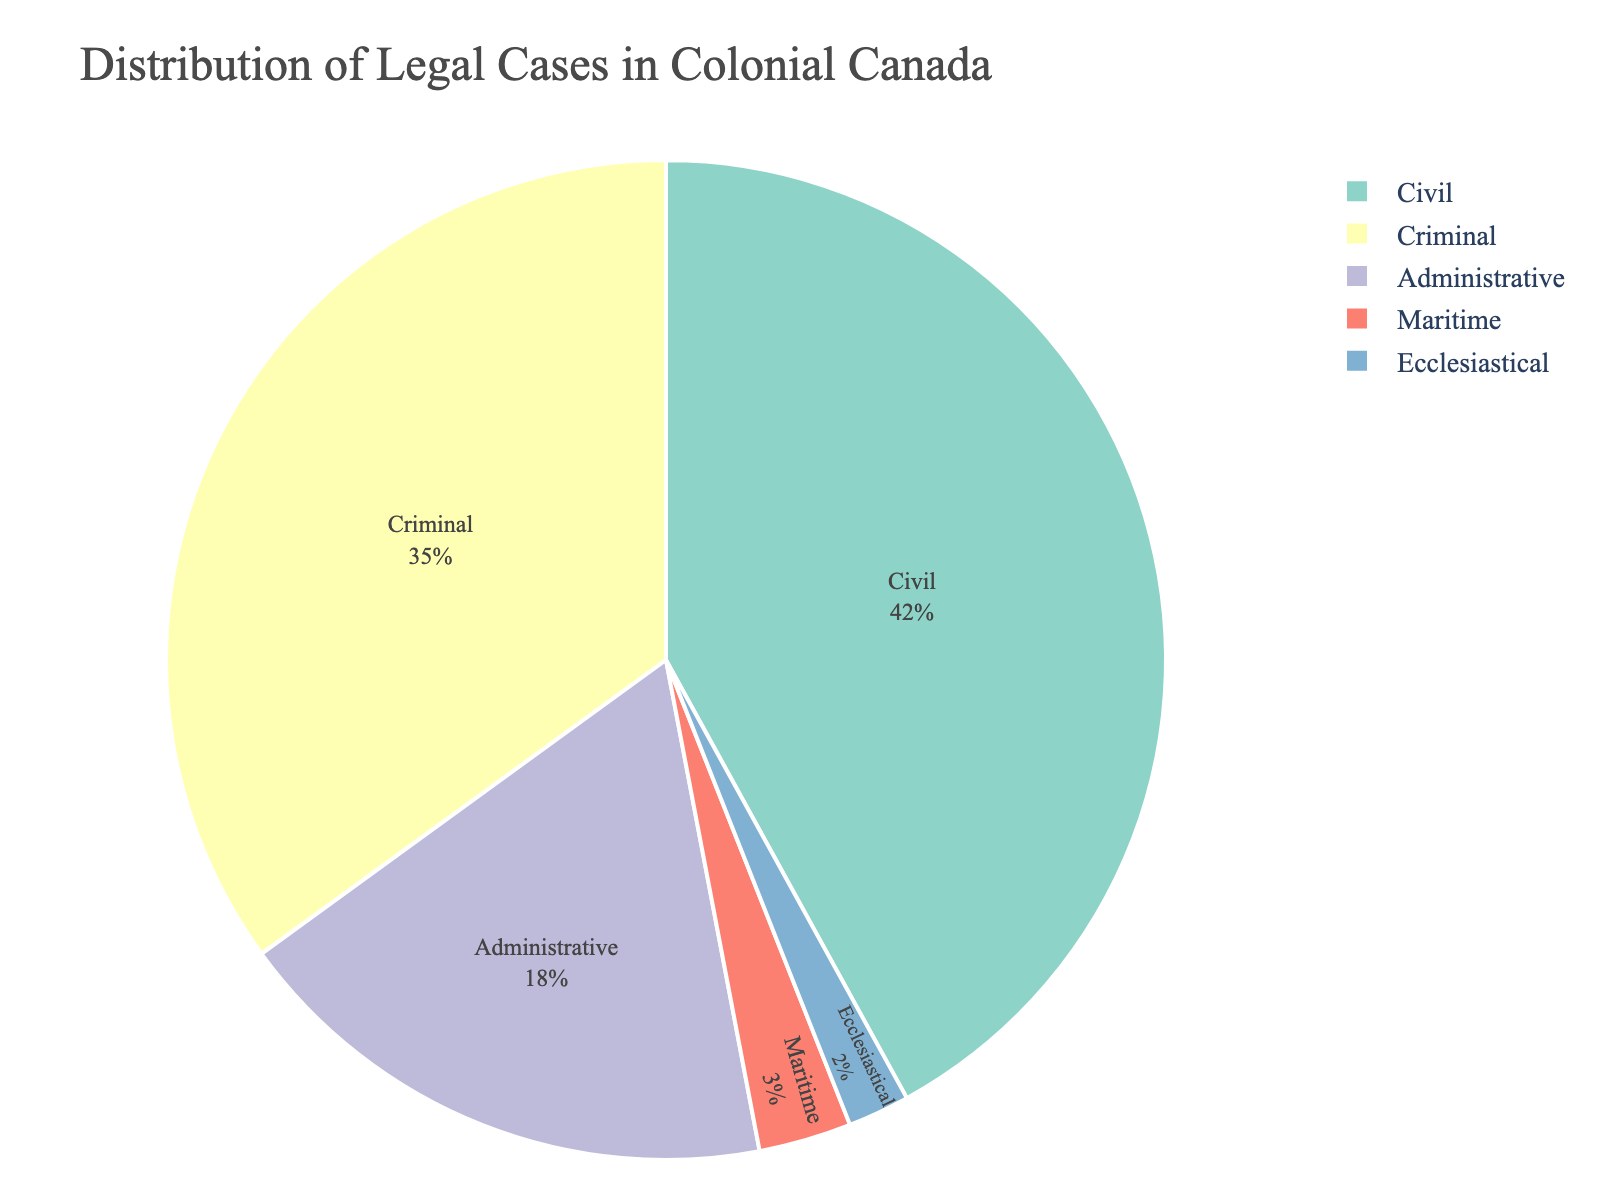What percentage of legal cases in colonial Canada were criminal cases? The pie chart shows the distribution of legal cases by type, with criminal cases representing a portion of the chart. According to the chart, criminal cases account for 35% of the total.
Answer: 35% Which type of legal case had the highest percentage in colonial Canada? By examining the pie chart, the segment with the largest percentage indicates the type with the highest occurrence. Civil cases have the highest percentage at 42%.
Answer: Civil How much more common were civil cases than administrative cases in colonial Canada? To find this, subtract the percentage of administrative cases from civil cases (42% - 18%). The difference is 24%.
Answer: 24% Which types of legal cases collectively made up less than 5% of the total? To determine which categories form less than 5%, look at the individual percentage values. Maritime (3%) and ecclesiastical (2%) cases together make up 5%, each being less than 5% individually.
Answer: Maritime and Ecclesiastical How does the number of administrative cases compare to maritime cases in colonial Canada? To compare, note the percentages of each case type. Administrative cases (18%) are significantly more common than maritime cases (3%).
Answer: Administrative cases are more common What is the combined percentage of non-criminal and non-civil cases in colonial Canada? Calculate the total percentage of administrative, maritime, and ecclesiastical cases by adding their percentages (18% + 3% + 2%). The combined percentage is 23%.
Answer: 23% Which section of the pie chart is visually the smallest, and what type of cases does it represent? The smallest segment on the pie chart visually identifies the smallest number of cases. The smallest section represents ecclesiastical cases at 2%.
Answer: Ecclesiastical What percentage of the total cases do the criminal and maritime cases represent together? Add the percentages of criminal cases (35%) and maritime cases (3%) to get the total. The combined percentage is 38%.
Answer: 38% Are civil cases more than twice as prevalent as administrative cases in colonial Canada? To determine if civil cases are more than double administrative cases, compare twice the percentage of administrative cases (18% * 2 = 36%) with the percentage of civil cases (42%). Since 42% > 36%, civil cases are more than twice as prevalent.
Answer: Yes Which types of legal cases together make up more than half of all cases in colonial Canada? Add the percentages of the top types until they exceed half. Criminal (35%) and civil (42%) together account for 77%, which is more than half.
Answer: Criminal and Civil 